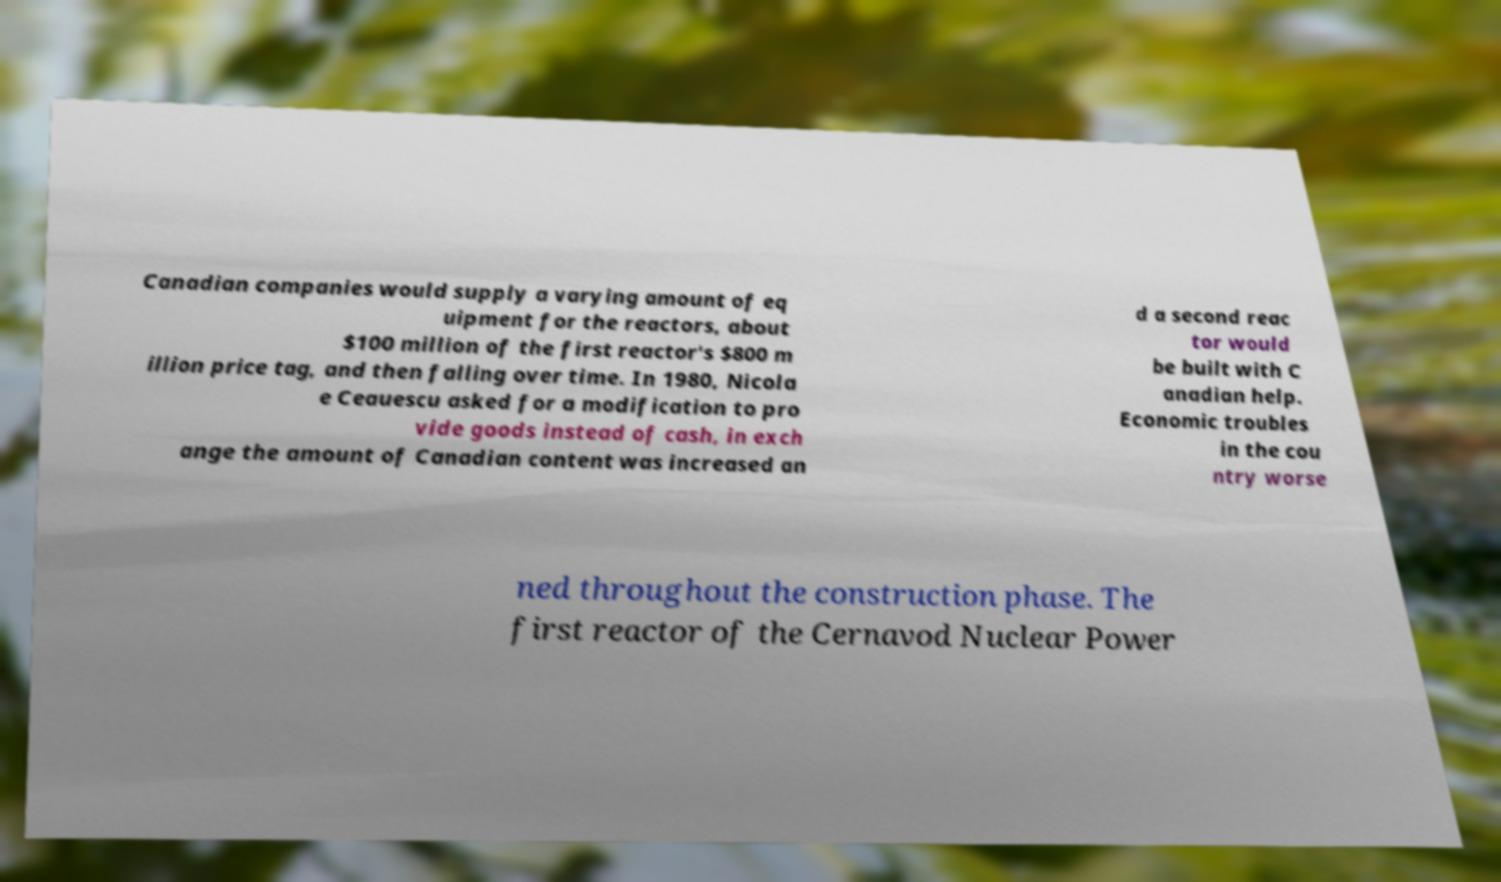Can you accurately transcribe the text from the provided image for me? Canadian companies would supply a varying amount of eq uipment for the reactors, about $100 million of the first reactor's $800 m illion price tag, and then falling over time. In 1980, Nicola e Ceauescu asked for a modification to pro vide goods instead of cash, in exch ange the amount of Canadian content was increased an d a second reac tor would be built with C anadian help. Economic troubles in the cou ntry worse ned throughout the construction phase. The first reactor of the Cernavod Nuclear Power 